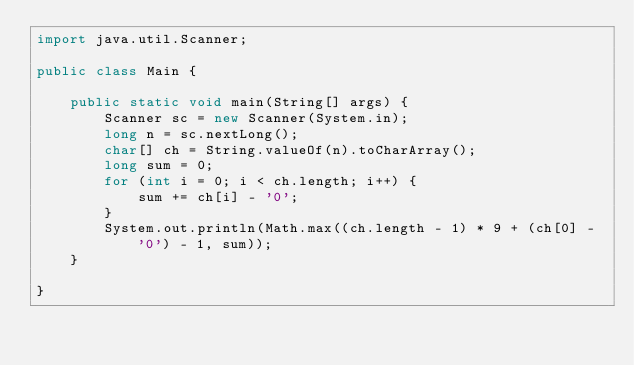<code> <loc_0><loc_0><loc_500><loc_500><_Java_>import java.util.Scanner;

public class Main {

    public static void main(String[] args) {
        Scanner sc = new Scanner(System.in);
        long n = sc.nextLong();
        char[] ch = String.valueOf(n).toCharArray();
        long sum = 0;
        for (int i = 0; i < ch.length; i++) {
            sum += ch[i] - '0';
        }
        System.out.println(Math.max((ch.length - 1) * 9 + (ch[0] - '0') - 1, sum));
    }

}
</code> 